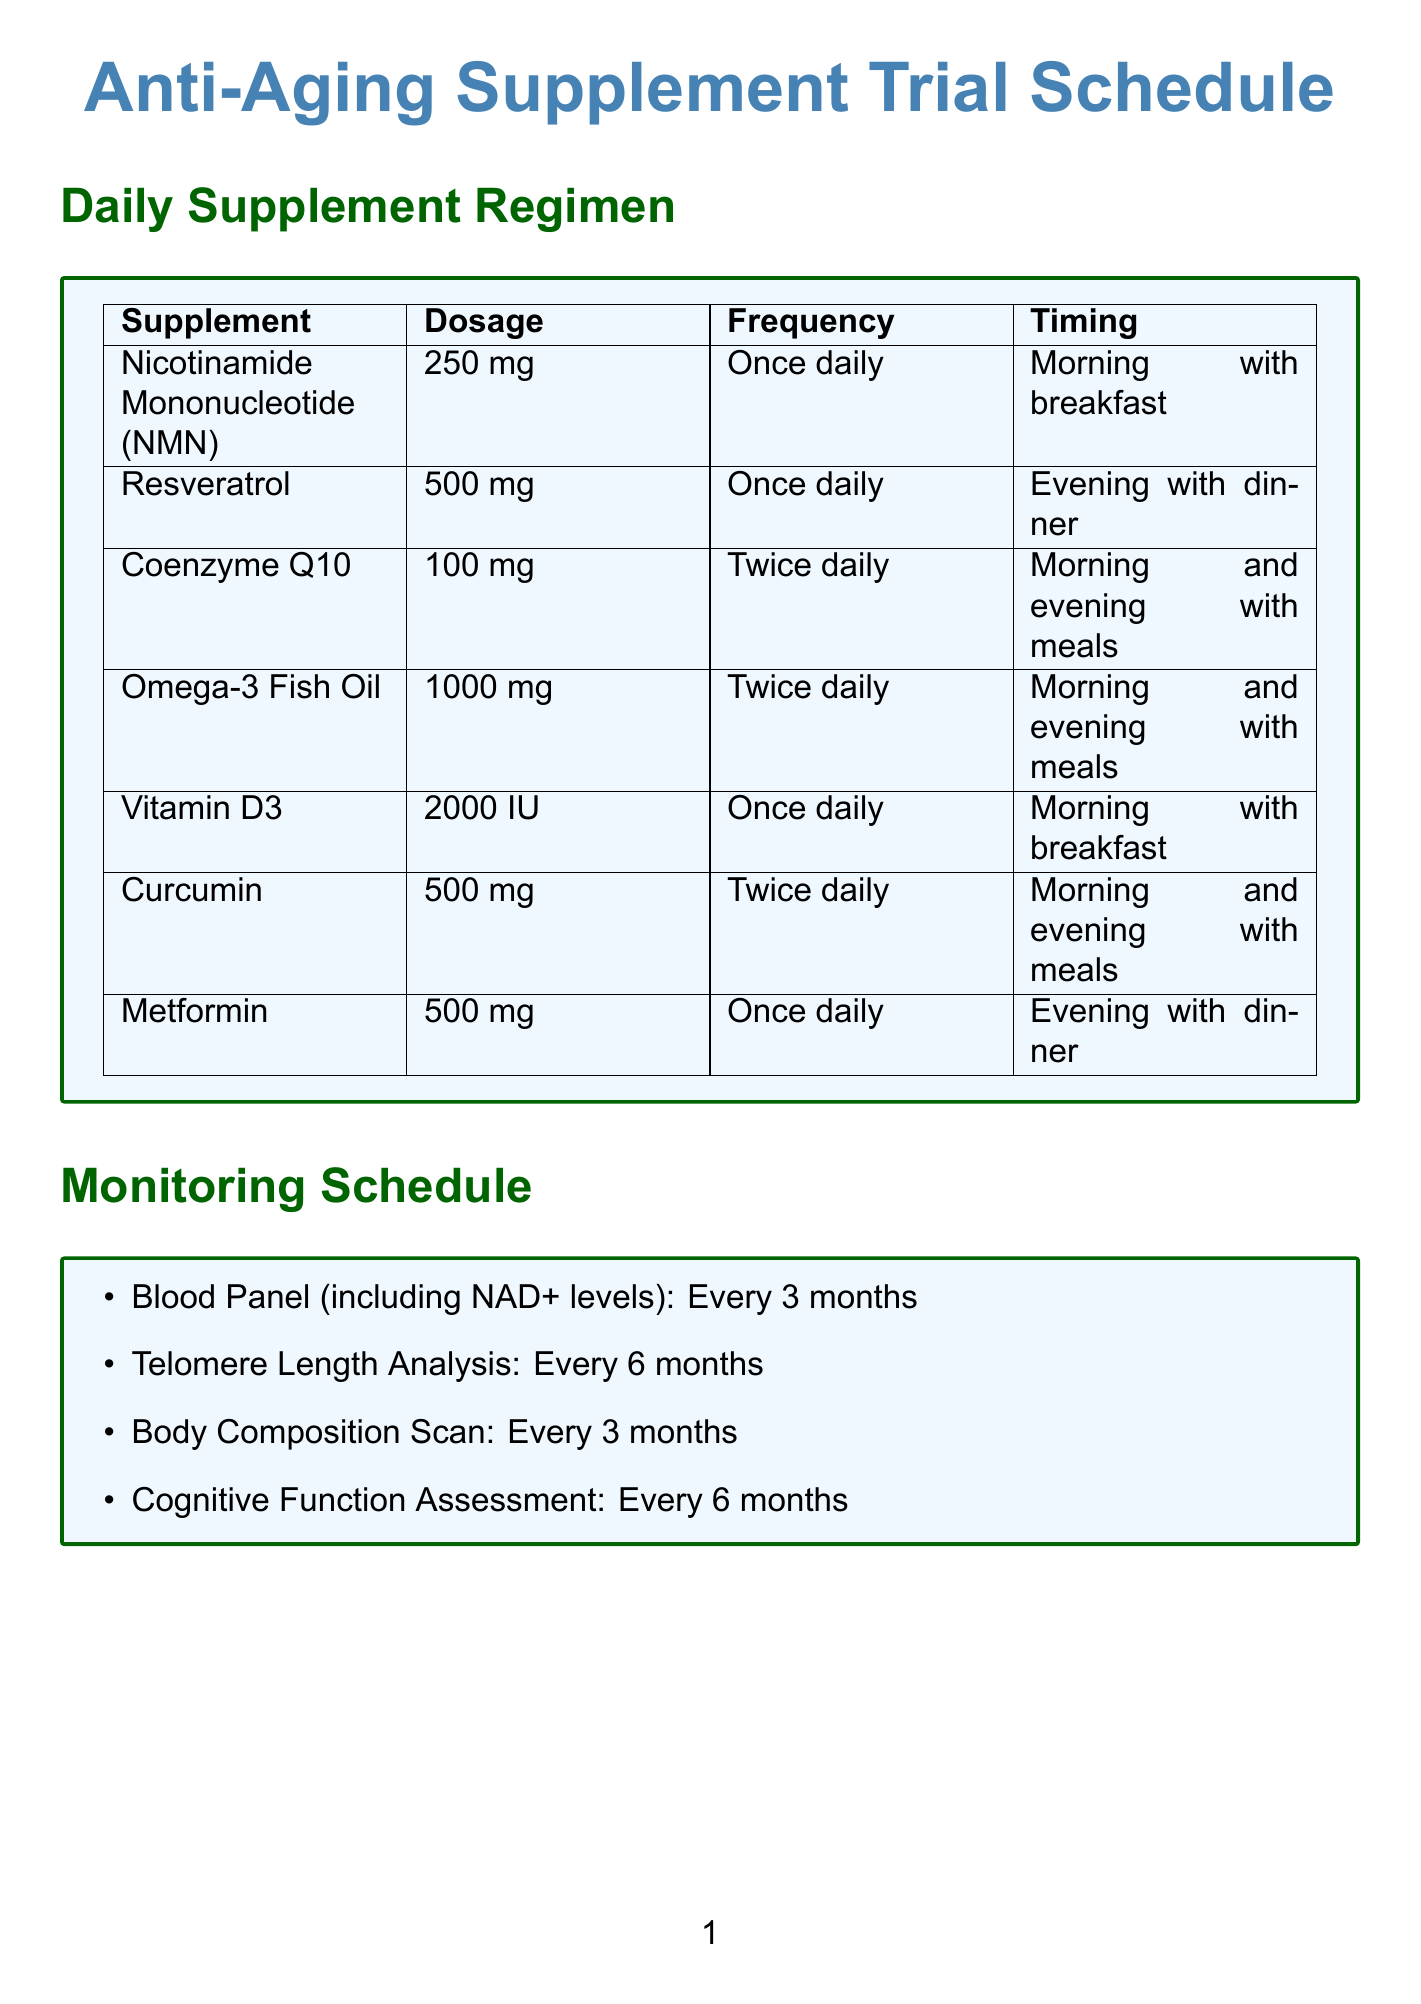What is the dosage of Nicotinamide Mononucleotide? The document states that Nicotinamide Mononucleotide (NMN) has a dosage of 250 mg.
Answer: 250 mg What is the timing for taking Resveratrol? According to the document, Resveratrol should be taken in the evening with dinner.
Answer: Evening with dinner How frequently should Coenzyme Q10 be taken? The document indicates that Coenzyme Q10 should be taken twice daily.
Answer: Twice daily What lifestyle activity is recommended 5 days per week? The document lists Intermittent Fasting as an activity recommended 5 days per week.
Answer: Intermittent Fasting How often are Blood Panels conducted? The document states that Blood Panels are required every 3 months.
Answer: Every 3 months What is a cautionary note mentioned in the document? One of the cautionary notes advises to consult with a healthcare professional before starting any supplement regimen.
Answer: Consult with a healthcare professional Which supplement is a prescription medication? The document identifies Metformin as the only prescription medication listed.
Answer: Metformin What dosage of Omega-3 Fish Oil is recommended? Omega-3 Fish Oil should be taken at a dosage of 1000 mg.
Answer: 1000 mg How frequently should Cognitive Function Assessments be performed? The document mentions that Cognitive Function Assessments are to be done every 6 months.
Answer: Every 6 months 